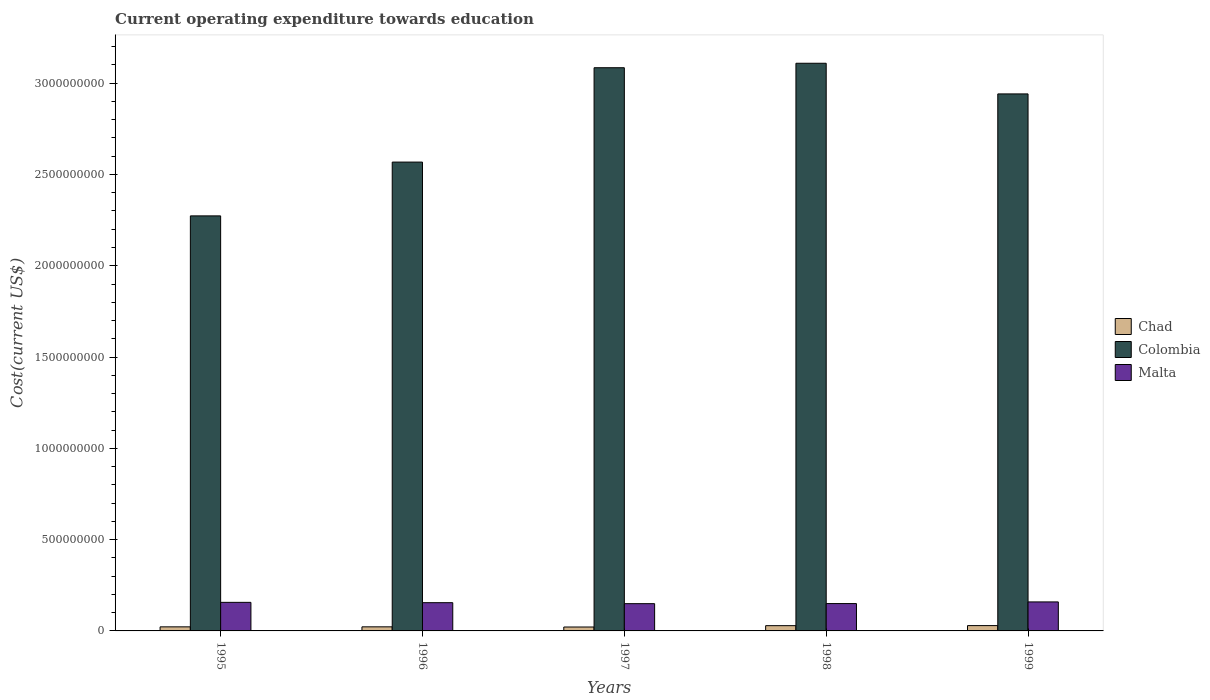How many different coloured bars are there?
Keep it short and to the point. 3. Are the number of bars per tick equal to the number of legend labels?
Provide a short and direct response. Yes. What is the expenditure towards education in Chad in 1998?
Provide a short and direct response. 2.88e+07. Across all years, what is the maximum expenditure towards education in Colombia?
Provide a short and direct response. 3.11e+09. Across all years, what is the minimum expenditure towards education in Colombia?
Ensure brevity in your answer.  2.27e+09. In which year was the expenditure towards education in Chad maximum?
Provide a short and direct response. 1999. What is the total expenditure towards education in Chad in the graph?
Your answer should be very brief. 1.24e+08. What is the difference between the expenditure towards education in Colombia in 1998 and that in 1999?
Make the answer very short. 1.68e+08. What is the difference between the expenditure towards education in Malta in 1998 and the expenditure towards education in Colombia in 1996?
Your response must be concise. -2.42e+09. What is the average expenditure towards education in Malta per year?
Make the answer very short. 1.54e+08. In the year 1997, what is the difference between the expenditure towards education in Chad and expenditure towards education in Malta?
Your answer should be compact. -1.28e+08. In how many years, is the expenditure towards education in Colombia greater than 500000000 US$?
Offer a terse response. 5. What is the ratio of the expenditure towards education in Malta in 1996 to that in 1999?
Your answer should be compact. 0.97. Is the expenditure towards education in Chad in 1995 less than that in 1997?
Ensure brevity in your answer.  No. Is the difference between the expenditure towards education in Chad in 1996 and 1998 greater than the difference between the expenditure towards education in Malta in 1996 and 1998?
Your answer should be very brief. No. What is the difference between the highest and the second highest expenditure towards education in Chad?
Offer a terse response. 3.50e+05. What is the difference between the highest and the lowest expenditure towards education in Chad?
Your response must be concise. 7.73e+06. What does the 1st bar from the left in 1996 represents?
Your answer should be compact. Chad. What does the 3rd bar from the right in 1999 represents?
Your response must be concise. Chad. Is it the case that in every year, the sum of the expenditure towards education in Chad and expenditure towards education in Colombia is greater than the expenditure towards education in Malta?
Make the answer very short. Yes. How many bars are there?
Give a very brief answer. 15. Are all the bars in the graph horizontal?
Offer a very short reply. No. What is the difference between two consecutive major ticks on the Y-axis?
Offer a terse response. 5.00e+08. Does the graph contain any zero values?
Your answer should be compact. No. Does the graph contain grids?
Your answer should be compact. No. Where does the legend appear in the graph?
Your response must be concise. Center right. How many legend labels are there?
Ensure brevity in your answer.  3. How are the legend labels stacked?
Your response must be concise. Vertical. What is the title of the graph?
Provide a succinct answer. Current operating expenditure towards education. Does "Upper middle income" appear as one of the legend labels in the graph?
Ensure brevity in your answer.  No. What is the label or title of the X-axis?
Offer a very short reply. Years. What is the label or title of the Y-axis?
Ensure brevity in your answer.  Cost(current US$). What is the Cost(current US$) in Chad in 1995?
Provide a short and direct response. 2.23e+07. What is the Cost(current US$) in Colombia in 1995?
Ensure brevity in your answer.  2.27e+09. What is the Cost(current US$) in Malta in 1995?
Your answer should be very brief. 1.56e+08. What is the Cost(current US$) in Chad in 1996?
Offer a terse response. 2.24e+07. What is the Cost(current US$) of Colombia in 1996?
Your answer should be compact. 2.57e+09. What is the Cost(current US$) of Malta in 1996?
Your answer should be very brief. 1.55e+08. What is the Cost(current US$) of Chad in 1997?
Offer a terse response. 2.14e+07. What is the Cost(current US$) in Colombia in 1997?
Your answer should be compact. 3.08e+09. What is the Cost(current US$) in Malta in 1997?
Offer a terse response. 1.49e+08. What is the Cost(current US$) of Chad in 1998?
Give a very brief answer. 2.88e+07. What is the Cost(current US$) in Colombia in 1998?
Ensure brevity in your answer.  3.11e+09. What is the Cost(current US$) of Malta in 1998?
Give a very brief answer. 1.50e+08. What is the Cost(current US$) of Chad in 1999?
Your answer should be compact. 2.91e+07. What is the Cost(current US$) of Colombia in 1999?
Keep it short and to the point. 2.94e+09. What is the Cost(current US$) in Malta in 1999?
Provide a succinct answer. 1.59e+08. Across all years, what is the maximum Cost(current US$) of Chad?
Ensure brevity in your answer.  2.91e+07. Across all years, what is the maximum Cost(current US$) in Colombia?
Your response must be concise. 3.11e+09. Across all years, what is the maximum Cost(current US$) of Malta?
Your response must be concise. 1.59e+08. Across all years, what is the minimum Cost(current US$) of Chad?
Your answer should be very brief. 2.14e+07. Across all years, what is the minimum Cost(current US$) in Colombia?
Provide a short and direct response. 2.27e+09. Across all years, what is the minimum Cost(current US$) in Malta?
Keep it short and to the point. 1.49e+08. What is the total Cost(current US$) of Chad in the graph?
Your answer should be very brief. 1.24e+08. What is the total Cost(current US$) of Colombia in the graph?
Offer a very short reply. 1.40e+1. What is the total Cost(current US$) in Malta in the graph?
Your answer should be compact. 7.69e+08. What is the difference between the Cost(current US$) of Chad in 1995 and that in 1996?
Make the answer very short. -2.79e+04. What is the difference between the Cost(current US$) of Colombia in 1995 and that in 1996?
Your response must be concise. -2.95e+08. What is the difference between the Cost(current US$) of Malta in 1995 and that in 1996?
Ensure brevity in your answer.  1.80e+06. What is the difference between the Cost(current US$) of Chad in 1995 and that in 1997?
Give a very brief answer. 9.39e+05. What is the difference between the Cost(current US$) in Colombia in 1995 and that in 1997?
Make the answer very short. -8.12e+08. What is the difference between the Cost(current US$) of Malta in 1995 and that in 1997?
Your answer should be compact. 7.13e+06. What is the difference between the Cost(current US$) in Chad in 1995 and that in 1998?
Offer a very short reply. -6.45e+06. What is the difference between the Cost(current US$) in Colombia in 1995 and that in 1998?
Ensure brevity in your answer.  -8.36e+08. What is the difference between the Cost(current US$) in Malta in 1995 and that in 1998?
Make the answer very short. 6.67e+06. What is the difference between the Cost(current US$) of Chad in 1995 and that in 1999?
Provide a succinct answer. -6.80e+06. What is the difference between the Cost(current US$) of Colombia in 1995 and that in 1999?
Keep it short and to the point. -6.68e+08. What is the difference between the Cost(current US$) of Malta in 1995 and that in 1999?
Provide a succinct answer. -2.41e+06. What is the difference between the Cost(current US$) in Chad in 1996 and that in 1997?
Make the answer very short. 9.66e+05. What is the difference between the Cost(current US$) in Colombia in 1996 and that in 1997?
Offer a terse response. -5.17e+08. What is the difference between the Cost(current US$) of Malta in 1996 and that in 1997?
Keep it short and to the point. 5.33e+06. What is the difference between the Cost(current US$) in Chad in 1996 and that in 1998?
Give a very brief answer. -6.42e+06. What is the difference between the Cost(current US$) in Colombia in 1996 and that in 1998?
Give a very brief answer. -5.41e+08. What is the difference between the Cost(current US$) in Malta in 1996 and that in 1998?
Provide a short and direct response. 4.87e+06. What is the difference between the Cost(current US$) of Chad in 1996 and that in 1999?
Your answer should be compact. -6.77e+06. What is the difference between the Cost(current US$) in Colombia in 1996 and that in 1999?
Provide a short and direct response. -3.73e+08. What is the difference between the Cost(current US$) in Malta in 1996 and that in 1999?
Offer a terse response. -4.20e+06. What is the difference between the Cost(current US$) in Chad in 1997 and that in 1998?
Provide a succinct answer. -7.38e+06. What is the difference between the Cost(current US$) in Colombia in 1997 and that in 1998?
Your answer should be very brief. -2.44e+07. What is the difference between the Cost(current US$) in Malta in 1997 and that in 1998?
Ensure brevity in your answer.  -4.62e+05. What is the difference between the Cost(current US$) in Chad in 1997 and that in 1999?
Your response must be concise. -7.73e+06. What is the difference between the Cost(current US$) of Colombia in 1997 and that in 1999?
Make the answer very short. 1.44e+08. What is the difference between the Cost(current US$) of Malta in 1997 and that in 1999?
Your response must be concise. -9.54e+06. What is the difference between the Cost(current US$) in Chad in 1998 and that in 1999?
Provide a succinct answer. -3.50e+05. What is the difference between the Cost(current US$) in Colombia in 1998 and that in 1999?
Offer a terse response. 1.68e+08. What is the difference between the Cost(current US$) in Malta in 1998 and that in 1999?
Your answer should be compact. -9.07e+06. What is the difference between the Cost(current US$) of Chad in 1995 and the Cost(current US$) of Colombia in 1996?
Provide a succinct answer. -2.55e+09. What is the difference between the Cost(current US$) of Chad in 1995 and the Cost(current US$) of Malta in 1996?
Your answer should be compact. -1.32e+08. What is the difference between the Cost(current US$) of Colombia in 1995 and the Cost(current US$) of Malta in 1996?
Offer a very short reply. 2.12e+09. What is the difference between the Cost(current US$) of Chad in 1995 and the Cost(current US$) of Colombia in 1997?
Ensure brevity in your answer.  -3.06e+09. What is the difference between the Cost(current US$) of Chad in 1995 and the Cost(current US$) of Malta in 1997?
Your response must be concise. -1.27e+08. What is the difference between the Cost(current US$) of Colombia in 1995 and the Cost(current US$) of Malta in 1997?
Keep it short and to the point. 2.12e+09. What is the difference between the Cost(current US$) in Chad in 1995 and the Cost(current US$) in Colombia in 1998?
Ensure brevity in your answer.  -3.09e+09. What is the difference between the Cost(current US$) in Chad in 1995 and the Cost(current US$) in Malta in 1998?
Provide a short and direct response. -1.27e+08. What is the difference between the Cost(current US$) of Colombia in 1995 and the Cost(current US$) of Malta in 1998?
Make the answer very short. 2.12e+09. What is the difference between the Cost(current US$) of Chad in 1995 and the Cost(current US$) of Colombia in 1999?
Keep it short and to the point. -2.92e+09. What is the difference between the Cost(current US$) of Chad in 1995 and the Cost(current US$) of Malta in 1999?
Keep it short and to the point. -1.37e+08. What is the difference between the Cost(current US$) of Colombia in 1995 and the Cost(current US$) of Malta in 1999?
Make the answer very short. 2.11e+09. What is the difference between the Cost(current US$) of Chad in 1996 and the Cost(current US$) of Colombia in 1997?
Keep it short and to the point. -3.06e+09. What is the difference between the Cost(current US$) of Chad in 1996 and the Cost(current US$) of Malta in 1997?
Offer a terse response. -1.27e+08. What is the difference between the Cost(current US$) of Colombia in 1996 and the Cost(current US$) of Malta in 1997?
Your answer should be compact. 2.42e+09. What is the difference between the Cost(current US$) of Chad in 1996 and the Cost(current US$) of Colombia in 1998?
Make the answer very short. -3.09e+09. What is the difference between the Cost(current US$) in Chad in 1996 and the Cost(current US$) in Malta in 1998?
Your answer should be very brief. -1.27e+08. What is the difference between the Cost(current US$) in Colombia in 1996 and the Cost(current US$) in Malta in 1998?
Offer a very short reply. 2.42e+09. What is the difference between the Cost(current US$) in Chad in 1996 and the Cost(current US$) in Colombia in 1999?
Make the answer very short. -2.92e+09. What is the difference between the Cost(current US$) in Chad in 1996 and the Cost(current US$) in Malta in 1999?
Your response must be concise. -1.36e+08. What is the difference between the Cost(current US$) of Colombia in 1996 and the Cost(current US$) of Malta in 1999?
Offer a very short reply. 2.41e+09. What is the difference between the Cost(current US$) in Chad in 1997 and the Cost(current US$) in Colombia in 1998?
Your response must be concise. -3.09e+09. What is the difference between the Cost(current US$) in Chad in 1997 and the Cost(current US$) in Malta in 1998?
Offer a terse response. -1.28e+08. What is the difference between the Cost(current US$) in Colombia in 1997 and the Cost(current US$) in Malta in 1998?
Your answer should be compact. 2.93e+09. What is the difference between the Cost(current US$) in Chad in 1997 and the Cost(current US$) in Colombia in 1999?
Give a very brief answer. -2.92e+09. What is the difference between the Cost(current US$) of Chad in 1997 and the Cost(current US$) of Malta in 1999?
Keep it short and to the point. -1.37e+08. What is the difference between the Cost(current US$) in Colombia in 1997 and the Cost(current US$) in Malta in 1999?
Offer a very short reply. 2.93e+09. What is the difference between the Cost(current US$) in Chad in 1998 and the Cost(current US$) in Colombia in 1999?
Offer a terse response. -2.91e+09. What is the difference between the Cost(current US$) of Chad in 1998 and the Cost(current US$) of Malta in 1999?
Provide a succinct answer. -1.30e+08. What is the difference between the Cost(current US$) of Colombia in 1998 and the Cost(current US$) of Malta in 1999?
Keep it short and to the point. 2.95e+09. What is the average Cost(current US$) of Chad per year?
Give a very brief answer. 2.48e+07. What is the average Cost(current US$) in Colombia per year?
Your response must be concise. 2.80e+09. What is the average Cost(current US$) of Malta per year?
Make the answer very short. 1.54e+08. In the year 1995, what is the difference between the Cost(current US$) of Chad and Cost(current US$) of Colombia?
Your answer should be very brief. -2.25e+09. In the year 1995, what is the difference between the Cost(current US$) of Chad and Cost(current US$) of Malta?
Provide a succinct answer. -1.34e+08. In the year 1995, what is the difference between the Cost(current US$) in Colombia and Cost(current US$) in Malta?
Make the answer very short. 2.12e+09. In the year 1996, what is the difference between the Cost(current US$) in Chad and Cost(current US$) in Colombia?
Make the answer very short. -2.55e+09. In the year 1996, what is the difference between the Cost(current US$) of Chad and Cost(current US$) of Malta?
Give a very brief answer. -1.32e+08. In the year 1996, what is the difference between the Cost(current US$) of Colombia and Cost(current US$) of Malta?
Make the answer very short. 2.41e+09. In the year 1997, what is the difference between the Cost(current US$) in Chad and Cost(current US$) in Colombia?
Ensure brevity in your answer.  -3.06e+09. In the year 1997, what is the difference between the Cost(current US$) of Chad and Cost(current US$) of Malta?
Offer a terse response. -1.28e+08. In the year 1997, what is the difference between the Cost(current US$) in Colombia and Cost(current US$) in Malta?
Provide a succinct answer. 2.94e+09. In the year 1998, what is the difference between the Cost(current US$) of Chad and Cost(current US$) of Colombia?
Provide a short and direct response. -3.08e+09. In the year 1998, what is the difference between the Cost(current US$) in Chad and Cost(current US$) in Malta?
Your answer should be very brief. -1.21e+08. In the year 1998, what is the difference between the Cost(current US$) of Colombia and Cost(current US$) of Malta?
Offer a very short reply. 2.96e+09. In the year 1999, what is the difference between the Cost(current US$) in Chad and Cost(current US$) in Colombia?
Offer a terse response. -2.91e+09. In the year 1999, what is the difference between the Cost(current US$) in Chad and Cost(current US$) in Malta?
Your response must be concise. -1.30e+08. In the year 1999, what is the difference between the Cost(current US$) of Colombia and Cost(current US$) of Malta?
Offer a very short reply. 2.78e+09. What is the ratio of the Cost(current US$) of Colombia in 1995 to that in 1996?
Keep it short and to the point. 0.89. What is the ratio of the Cost(current US$) in Malta in 1995 to that in 1996?
Your answer should be compact. 1.01. What is the ratio of the Cost(current US$) of Chad in 1995 to that in 1997?
Your answer should be very brief. 1.04. What is the ratio of the Cost(current US$) in Colombia in 1995 to that in 1997?
Offer a very short reply. 0.74. What is the ratio of the Cost(current US$) in Malta in 1995 to that in 1997?
Your answer should be very brief. 1.05. What is the ratio of the Cost(current US$) of Chad in 1995 to that in 1998?
Your response must be concise. 0.78. What is the ratio of the Cost(current US$) in Colombia in 1995 to that in 1998?
Your answer should be very brief. 0.73. What is the ratio of the Cost(current US$) of Malta in 1995 to that in 1998?
Give a very brief answer. 1.04. What is the ratio of the Cost(current US$) in Chad in 1995 to that in 1999?
Ensure brevity in your answer.  0.77. What is the ratio of the Cost(current US$) of Colombia in 1995 to that in 1999?
Provide a short and direct response. 0.77. What is the ratio of the Cost(current US$) in Malta in 1995 to that in 1999?
Your answer should be compact. 0.98. What is the ratio of the Cost(current US$) in Chad in 1996 to that in 1997?
Offer a very short reply. 1.05. What is the ratio of the Cost(current US$) in Colombia in 1996 to that in 1997?
Give a very brief answer. 0.83. What is the ratio of the Cost(current US$) in Malta in 1996 to that in 1997?
Offer a terse response. 1.04. What is the ratio of the Cost(current US$) in Chad in 1996 to that in 1998?
Give a very brief answer. 0.78. What is the ratio of the Cost(current US$) in Colombia in 1996 to that in 1998?
Your response must be concise. 0.83. What is the ratio of the Cost(current US$) in Malta in 1996 to that in 1998?
Make the answer very short. 1.03. What is the ratio of the Cost(current US$) in Chad in 1996 to that in 1999?
Keep it short and to the point. 0.77. What is the ratio of the Cost(current US$) in Colombia in 1996 to that in 1999?
Give a very brief answer. 0.87. What is the ratio of the Cost(current US$) of Malta in 1996 to that in 1999?
Your answer should be compact. 0.97. What is the ratio of the Cost(current US$) of Chad in 1997 to that in 1998?
Your answer should be very brief. 0.74. What is the ratio of the Cost(current US$) in Chad in 1997 to that in 1999?
Offer a terse response. 0.73. What is the ratio of the Cost(current US$) in Colombia in 1997 to that in 1999?
Keep it short and to the point. 1.05. What is the ratio of the Cost(current US$) of Malta in 1997 to that in 1999?
Your answer should be compact. 0.94. What is the ratio of the Cost(current US$) in Colombia in 1998 to that in 1999?
Your answer should be compact. 1.06. What is the ratio of the Cost(current US$) in Malta in 1998 to that in 1999?
Provide a short and direct response. 0.94. What is the difference between the highest and the second highest Cost(current US$) of Chad?
Give a very brief answer. 3.50e+05. What is the difference between the highest and the second highest Cost(current US$) of Colombia?
Your response must be concise. 2.44e+07. What is the difference between the highest and the second highest Cost(current US$) in Malta?
Make the answer very short. 2.41e+06. What is the difference between the highest and the lowest Cost(current US$) in Chad?
Make the answer very short. 7.73e+06. What is the difference between the highest and the lowest Cost(current US$) of Colombia?
Offer a terse response. 8.36e+08. What is the difference between the highest and the lowest Cost(current US$) of Malta?
Provide a short and direct response. 9.54e+06. 